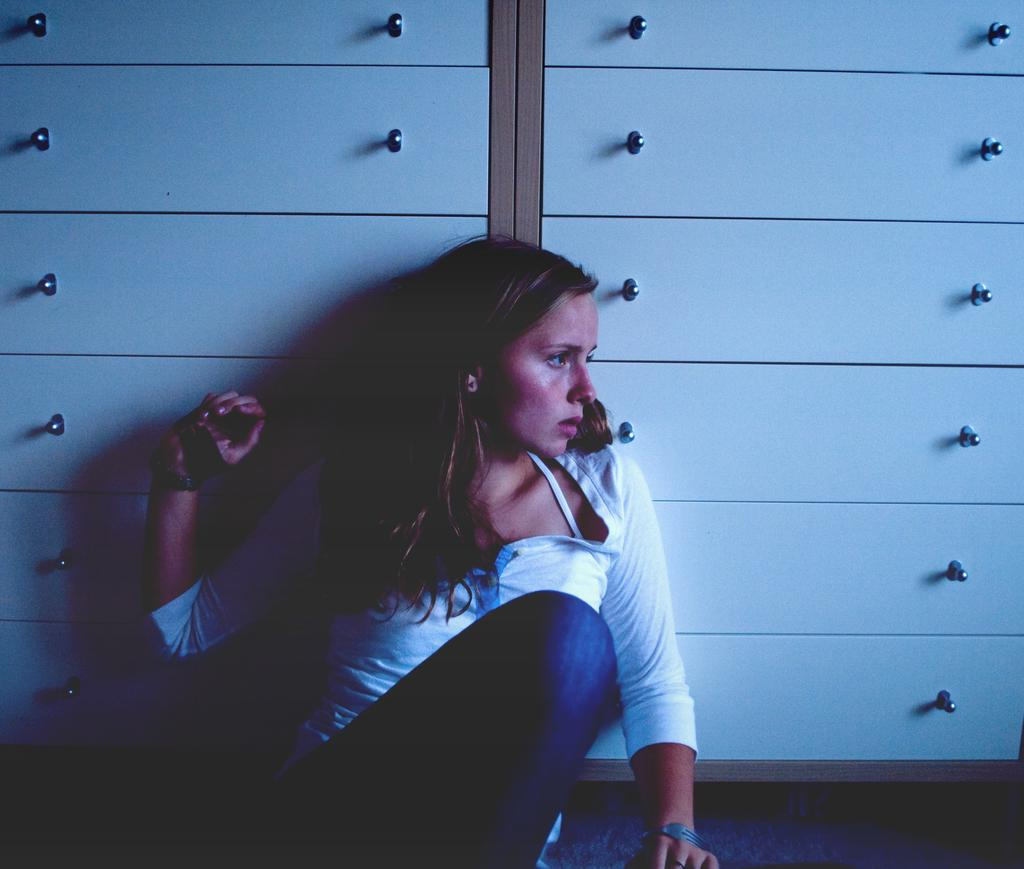Who is present in the image? There is a woman in the image. What is the woman wearing? The woman is wearing a white and blue dress. What is the woman's position in the image? The woman is sitting on the floor. What can be seen in the background of the image? There are drawers in the background of the image. What is the color of the drawers? The drawers are white in color. What type of wrench is the woman using in the image? There is no wrench present in the image, and the woman is not interacting with a user. 